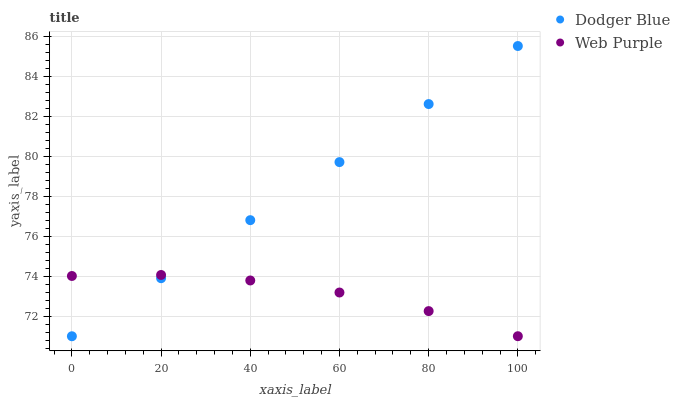Does Web Purple have the minimum area under the curve?
Answer yes or no. Yes. Does Dodger Blue have the maximum area under the curve?
Answer yes or no. Yes. Does Dodger Blue have the minimum area under the curve?
Answer yes or no. No. Is Dodger Blue the smoothest?
Answer yes or no. Yes. Is Web Purple the roughest?
Answer yes or no. Yes. Is Dodger Blue the roughest?
Answer yes or no. No. Does Dodger Blue have the lowest value?
Answer yes or no. Yes. Does Dodger Blue have the highest value?
Answer yes or no. Yes. Does Web Purple intersect Dodger Blue?
Answer yes or no. Yes. Is Web Purple less than Dodger Blue?
Answer yes or no. No. Is Web Purple greater than Dodger Blue?
Answer yes or no. No. 